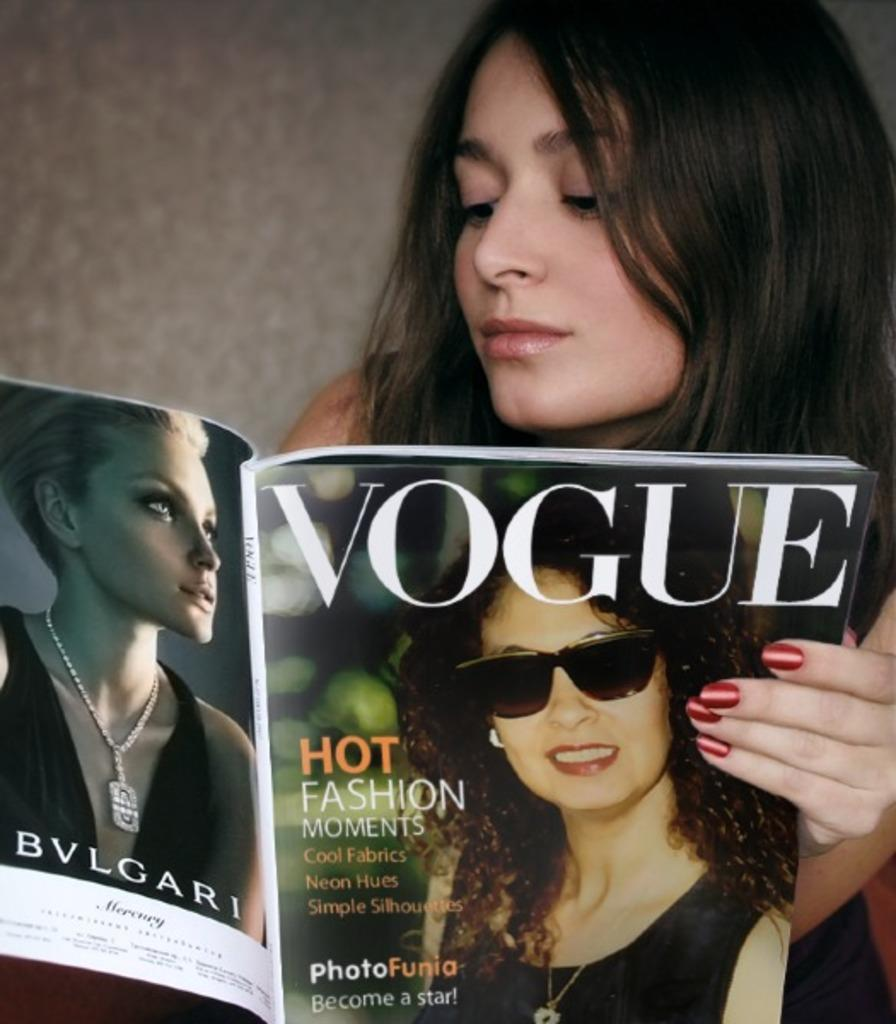Who is present in the image? There is a woman in the image. What is the woman holding in the image? The woman is holding a book. What is the woman doing with the book? The woman is reading the book. What can be seen behind the woman in the image? There is a wall behind the woman. What type of oatmeal is the woman eating in the image? There is no oatmeal present in the image; the woman is reading a book. What is the woman's interest in the book she is reading? The image does not provide information about the woman's interest in the book she is reading. 